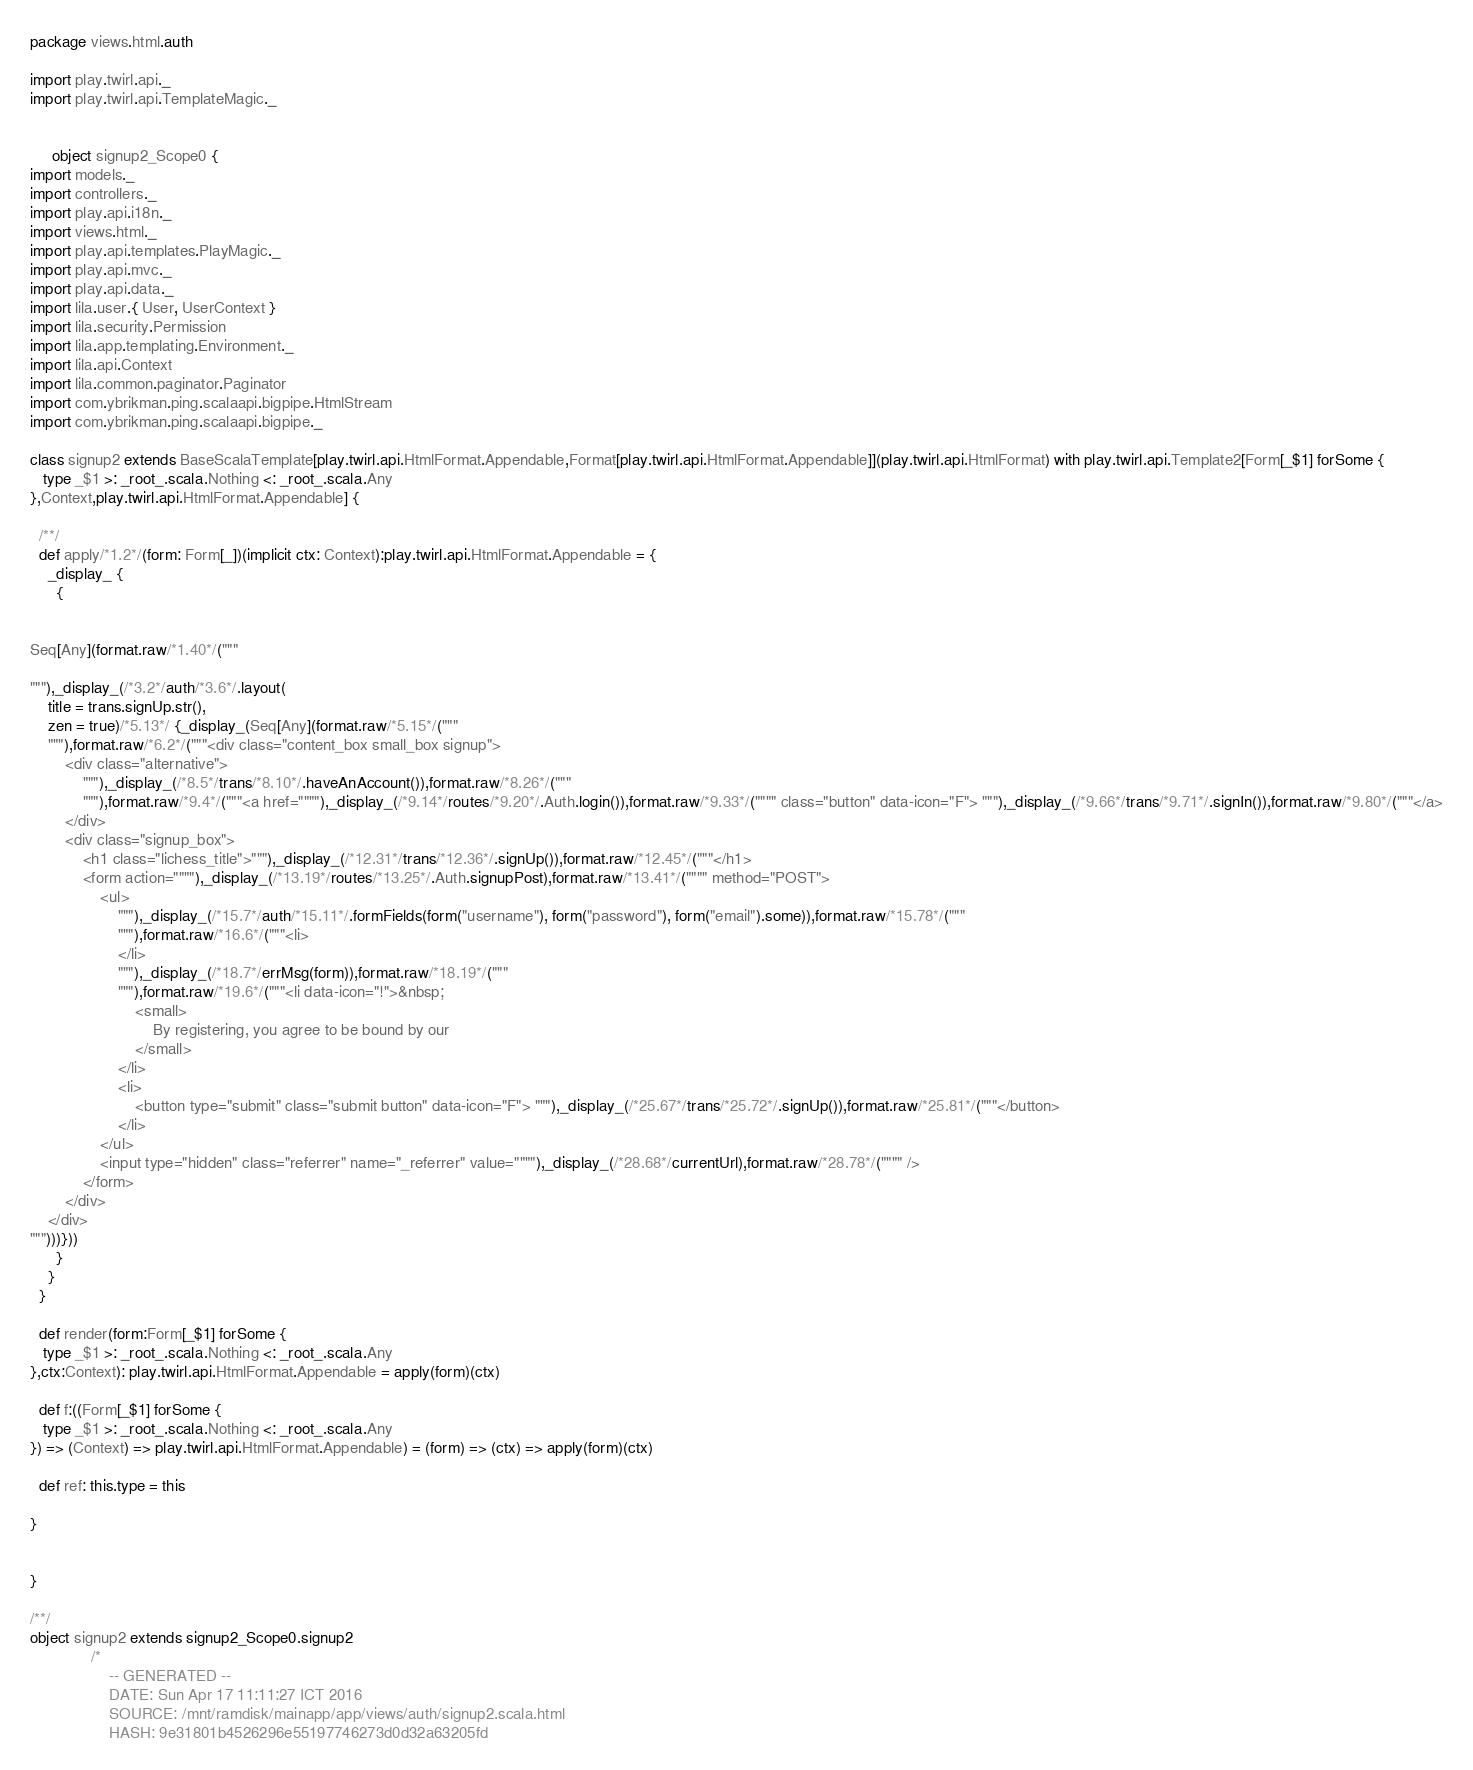Convert code to text. <code><loc_0><loc_0><loc_500><loc_500><_Scala_>
package views.html.auth

import play.twirl.api._
import play.twirl.api.TemplateMagic._


     object signup2_Scope0 {
import models._
import controllers._
import play.api.i18n._
import views.html._
import play.api.templates.PlayMagic._
import play.api.mvc._
import play.api.data._
import lila.user.{ User, UserContext }
import lila.security.Permission
import lila.app.templating.Environment._
import lila.api.Context
import lila.common.paginator.Paginator
import com.ybrikman.ping.scalaapi.bigpipe.HtmlStream
import com.ybrikman.ping.scalaapi.bigpipe._

class signup2 extends BaseScalaTemplate[play.twirl.api.HtmlFormat.Appendable,Format[play.twirl.api.HtmlFormat.Appendable]](play.twirl.api.HtmlFormat) with play.twirl.api.Template2[Form[_$1] forSome { 
   type _$1 >: _root_.scala.Nothing <: _root_.scala.Any
},Context,play.twirl.api.HtmlFormat.Appendable] {

  /**/
  def apply/*1.2*/(form: Form[_])(implicit ctx: Context):play.twirl.api.HtmlFormat.Appendable = {
    _display_ {
      {


Seq[Any](format.raw/*1.40*/("""

"""),_display_(/*3.2*/auth/*3.6*/.layout(
	title = trans.signUp.str(),
	zen = true)/*5.13*/ {_display_(Seq[Any](format.raw/*5.15*/("""
	"""),format.raw/*6.2*/("""<div class="content_box small_box signup">
		<div class="alternative">
			"""),_display_(/*8.5*/trans/*8.10*/.haveAnAccount()),format.raw/*8.26*/("""
			"""),format.raw/*9.4*/("""<a href=""""),_display_(/*9.14*/routes/*9.20*/.Auth.login()),format.raw/*9.33*/("""" class="button" data-icon="F"> """),_display_(/*9.66*/trans/*9.71*/.signIn()),format.raw/*9.80*/("""</a>
		</div>
		<div class="signup_box">
			<h1 class="lichess_title">"""),_display_(/*12.31*/trans/*12.36*/.signUp()),format.raw/*12.45*/("""</h1>
			<form action=""""),_display_(/*13.19*/routes/*13.25*/.Auth.signupPost),format.raw/*13.41*/("""" method="POST">
				<ul>
					"""),_display_(/*15.7*/auth/*15.11*/.formFields(form("username"), form("password"), form("email").some)),format.raw/*15.78*/("""
					"""),format.raw/*16.6*/("""<li>
					</li>
					"""),_display_(/*18.7*/errMsg(form)),format.raw/*18.19*/("""
					"""),format.raw/*19.6*/("""<li data-icon="!">&nbsp;
						<small>
							By registering, you agree to be bound by our
						</small>
					</li>
					<li>
						<button type="submit" class="submit button" data-icon="F"> """),_display_(/*25.67*/trans/*25.72*/.signUp()),format.raw/*25.81*/("""</button>
					</li>
				</ul>
				<input type="hidden" class="referrer" name="_referrer" value=""""),_display_(/*28.68*/currentUrl),format.raw/*28.78*/("""" />
			</form>
		</div>
	</div>
""")))}))
      }
    }
  }

  def render(form:Form[_$1] forSome { 
   type _$1 >: _root_.scala.Nothing <: _root_.scala.Any
},ctx:Context): play.twirl.api.HtmlFormat.Appendable = apply(form)(ctx)

  def f:((Form[_$1] forSome { 
   type _$1 >: _root_.scala.Nothing <: _root_.scala.Any
}) => (Context) => play.twirl.api.HtmlFormat.Appendable) = (form) => (ctx) => apply(form)(ctx)

  def ref: this.type = this

}


}

/**/
object signup2 extends signup2_Scope0.signup2
              /*
                  -- GENERATED --
                  DATE: Sun Apr 17 11:11:27 ICT 2016
                  SOURCE: /mnt/ramdisk/mainapp/app/views/auth/signup2.scala.html
                  HASH: 9e31801b4526296e55197746273d0d32a63205fd</code> 